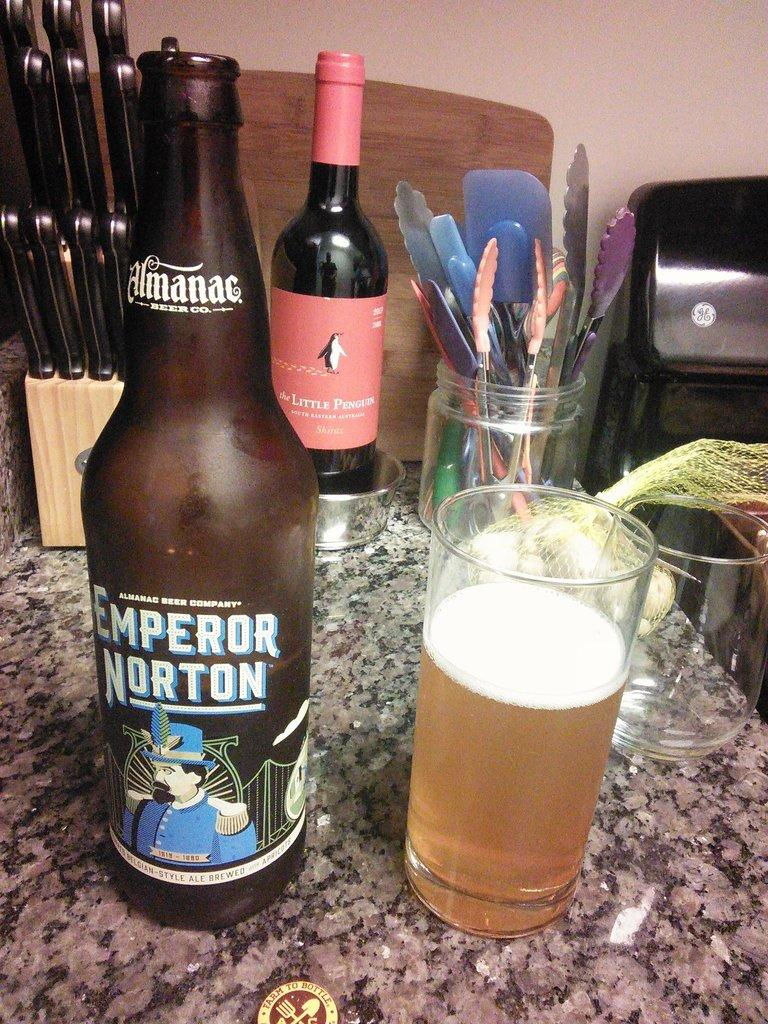<image>
Present a compact description of the photo's key features. Emperor Norton beer that is on a counter with a glass, wine and knives 